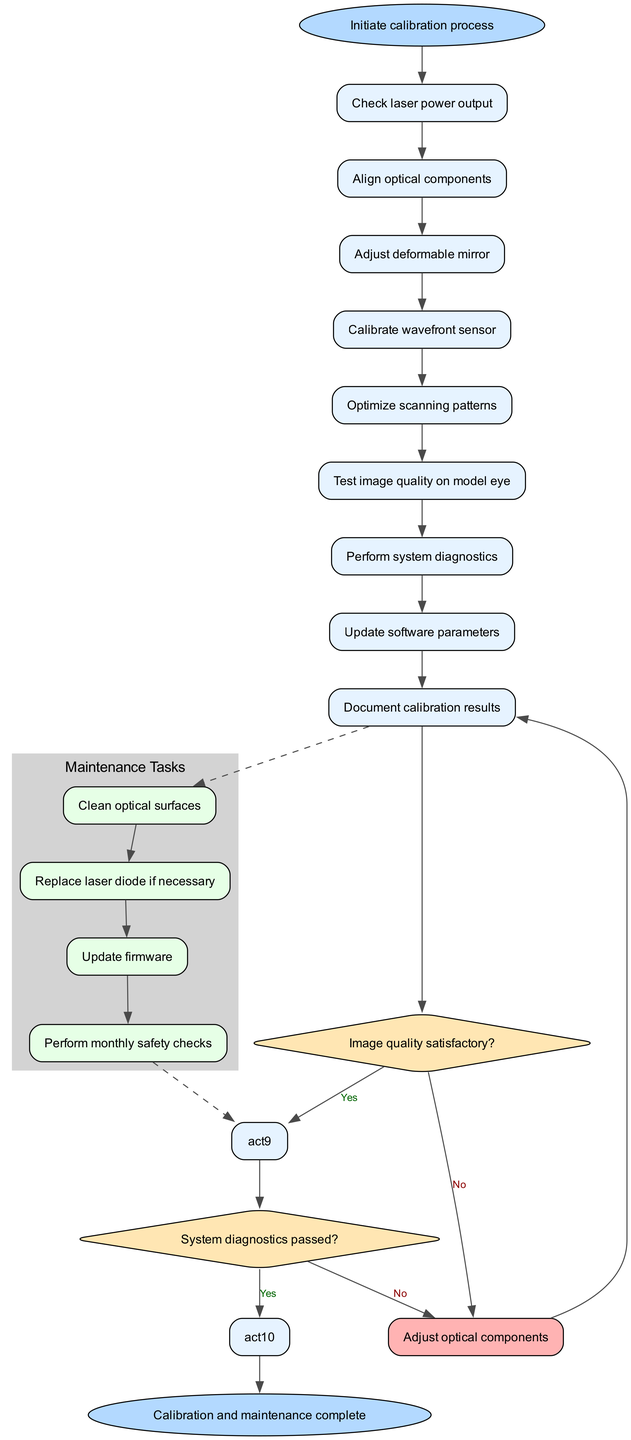what is the starting point of the calibration process? The diagram indicates the starting point is labeled as "Initiate calibration process," which is the first node in the workflow.
Answer: Initiate calibration process how many activities are involved in the calibration process? The diagram depicts a total of nine activities listed sequentially, from checking laser power output to documenting calibration results.
Answer: 9 what is the first activity listed in the diagram? The first activity in the sequence is "Check laser power output," which is the initial action to be taken in the calibration process.
Answer: Check laser power output what decision point asks about image quality? The decision point regarding image quality is "Image quality satisfactory?" which requires a yes or no answer to determine the next step in the flow.
Answer: Image quality satisfactory? what happens if the image quality is not satisfactory? If the image quality is deemed not satisfactory, the process leads to the action "Adjust optical components" to attempt to rectify the issue before proceeding.
Answer: Adjust optical components how many maintenance tasks are listed in the diagram? The diagram outlines four maintenance tasks specified in a cluster labeled "Maintenance Tasks," showing the additional steps required to maintain the system.
Answer: 4 what is the last task to complete after maintenance tasks? The last task required after all maintenance tasks is "Perform monthly safety checks," completing the cycle before returning to the process.
Answer: Perform monthly safety checks what do you do if the system diagnostics have not passed? If the system diagnostics do not pass, the step to take is to "Troubleshoot and repeat diagnostics," ensuring the system is functioning correctly before completion.
Answer: Troubleshoot and repeat diagnostics what shape represents decision points in the diagram? The shape used to represent decision points in the diagram is a diamond, indicating a question that requires a binary response.
Answer: Diamond 